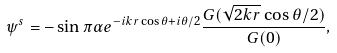Convert formula to latex. <formula><loc_0><loc_0><loc_500><loc_500>\psi ^ { s } = - \sin \pi \alpha e ^ { - i k r \cos \theta + i \theta / 2 } \frac { G ( \sqrt { 2 k r } \cos \theta / 2 ) } { G ( 0 ) } ,</formula> 